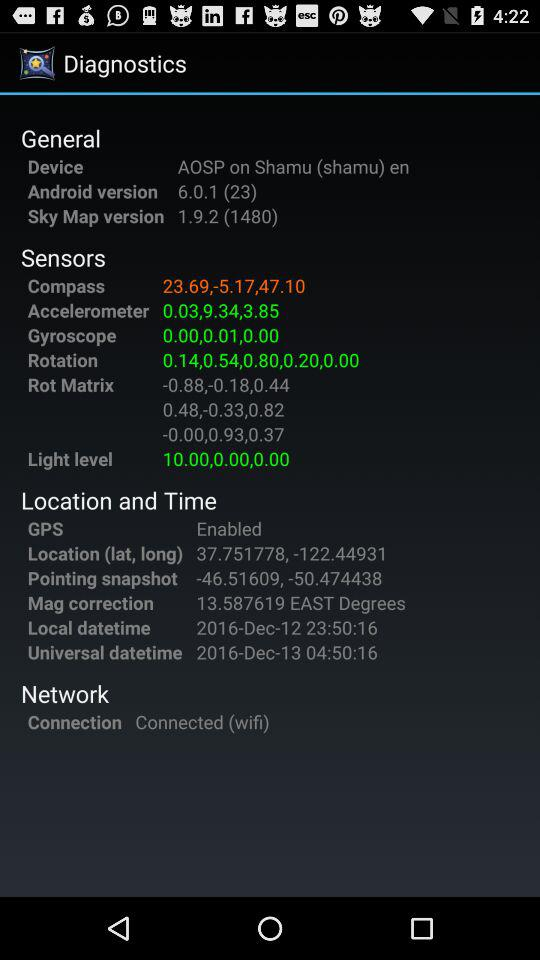What is the status of the connection? The status of the connection is "Connected". 